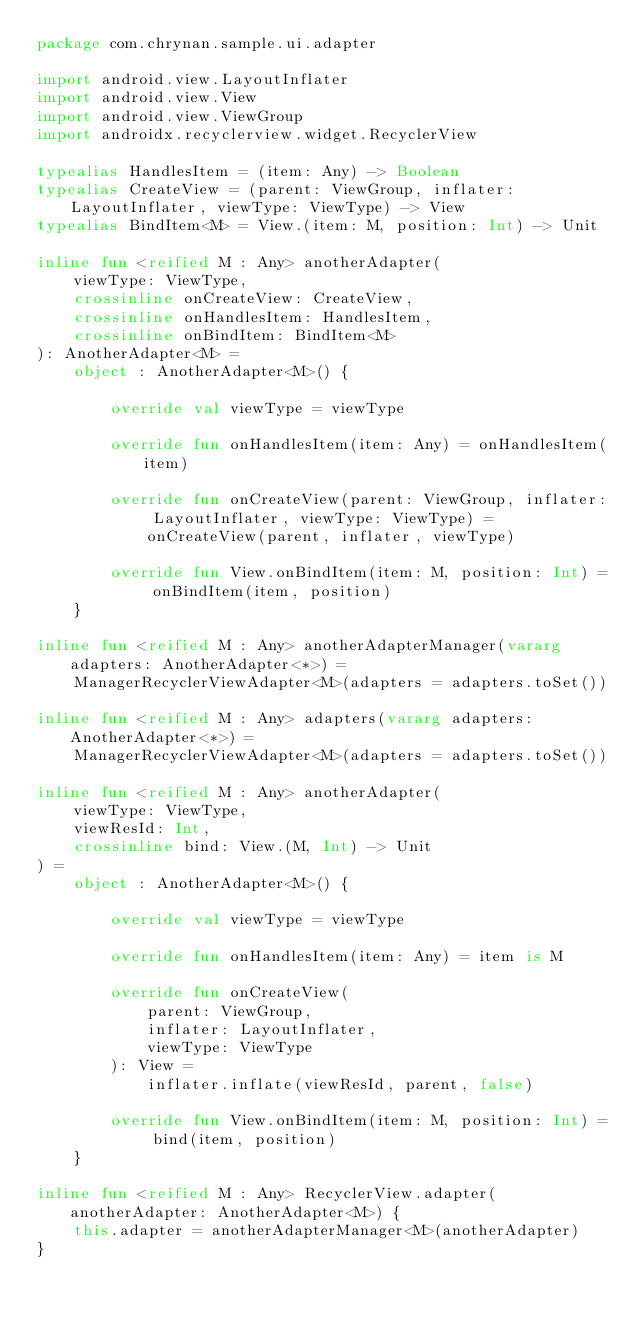Convert code to text. <code><loc_0><loc_0><loc_500><loc_500><_Kotlin_>package com.chrynan.sample.ui.adapter

import android.view.LayoutInflater
import android.view.View
import android.view.ViewGroup
import androidx.recyclerview.widget.RecyclerView

typealias HandlesItem = (item: Any) -> Boolean
typealias CreateView = (parent: ViewGroup, inflater: LayoutInflater, viewType: ViewType) -> View
typealias BindItem<M> = View.(item: M, position: Int) -> Unit

inline fun <reified M : Any> anotherAdapter(
    viewType: ViewType,
    crossinline onCreateView: CreateView,
    crossinline onHandlesItem: HandlesItem,
    crossinline onBindItem: BindItem<M>
): AnotherAdapter<M> =
    object : AnotherAdapter<M>() {

        override val viewType = viewType

        override fun onHandlesItem(item: Any) = onHandlesItem(item)

        override fun onCreateView(parent: ViewGroup, inflater: LayoutInflater, viewType: ViewType) =
            onCreateView(parent, inflater, viewType)

        override fun View.onBindItem(item: M, position: Int) = onBindItem(item, position)
    }

inline fun <reified M : Any> anotherAdapterManager(vararg adapters: AnotherAdapter<*>) =
    ManagerRecyclerViewAdapter<M>(adapters = adapters.toSet())

inline fun <reified M : Any> adapters(vararg adapters: AnotherAdapter<*>) =
    ManagerRecyclerViewAdapter<M>(adapters = adapters.toSet())

inline fun <reified M : Any> anotherAdapter(
    viewType: ViewType,
    viewResId: Int,
    crossinline bind: View.(M, Int) -> Unit
) =
    object : AnotherAdapter<M>() {

        override val viewType = viewType

        override fun onHandlesItem(item: Any) = item is M

        override fun onCreateView(
            parent: ViewGroup,
            inflater: LayoutInflater,
            viewType: ViewType
        ): View =
            inflater.inflate(viewResId, parent, false)

        override fun View.onBindItem(item: M, position: Int) = bind(item, position)
    }

inline fun <reified M : Any> RecyclerView.adapter(anotherAdapter: AnotherAdapter<M>) {
    this.adapter = anotherAdapterManager<M>(anotherAdapter)
}
</code> 